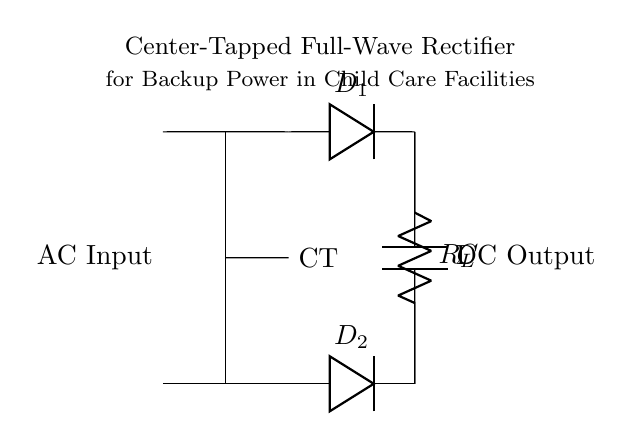What type of rectifier is shown in the circuit? The circuit diagram indicates a center-tapped full-wave rectifier, as indicated by its configuration involving two diodes connected to a center tap of the transformer.
Answer: center-tapped full-wave rectifier How many diodes are present in the circuit? The circuit diagram includes two diodes, labeled D1 and D2, which are essential for the rectification process.
Answer: two What is the function of the capacitor in this circuit? The capacitor smooths the output voltage by filtering the ripples produced after rectification, thus providing a more stable direct current output.
Answer: smoothing In what configuration is the transformer connected? The transformer is connected with a center tap, which divides the secondary winding into two equal halves, allowing each half to conduct during different halves of the input AC cycle.
Answer: center-tap What is the symbol representing the load resistor in the circuit? The load resistor is represented by the letter 'R' in the diagram, which is connected between the two output points of the diodes.
Answer: R What happens to the current during the positive cycle of the AC input? During the positive cycle, diode D1 conducts, allowing current to flow through the load resistor and charge the capacitor, resulting in a positive output voltage.
Answer: D1 conducts How does this circuit affect the output voltage? The output voltage is rectified and smoothed, leading to a higher DC voltage level than what is provided at the AC input, making it suitable for powering DC loads.
Answer: higher DC voltage 